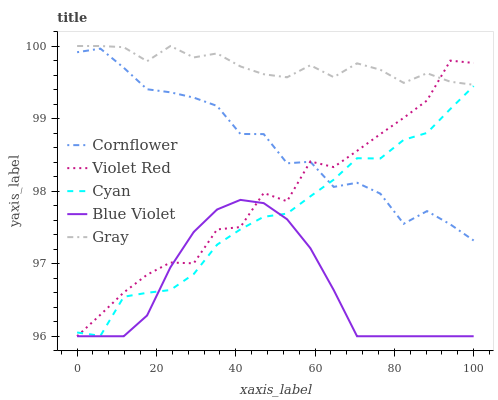Does Blue Violet have the minimum area under the curve?
Answer yes or no. Yes. Does Gray have the maximum area under the curve?
Answer yes or no. Yes. Does Violet Red have the minimum area under the curve?
Answer yes or no. No. Does Violet Red have the maximum area under the curve?
Answer yes or no. No. Is Blue Violet the smoothest?
Answer yes or no. Yes. Is Violet Red the roughest?
Answer yes or no. Yes. Is Gray the smoothest?
Answer yes or no. No. Is Gray the roughest?
Answer yes or no. No. Does Gray have the lowest value?
Answer yes or no. No. Does Gray have the highest value?
Answer yes or no. Yes. Does Violet Red have the highest value?
Answer yes or no. No. Is Cyan less than Gray?
Answer yes or no. Yes. Is Gray greater than Cornflower?
Answer yes or no. Yes. Does Blue Violet intersect Violet Red?
Answer yes or no. Yes. Is Blue Violet less than Violet Red?
Answer yes or no. No. Is Blue Violet greater than Violet Red?
Answer yes or no. No. Does Cyan intersect Gray?
Answer yes or no. No. 